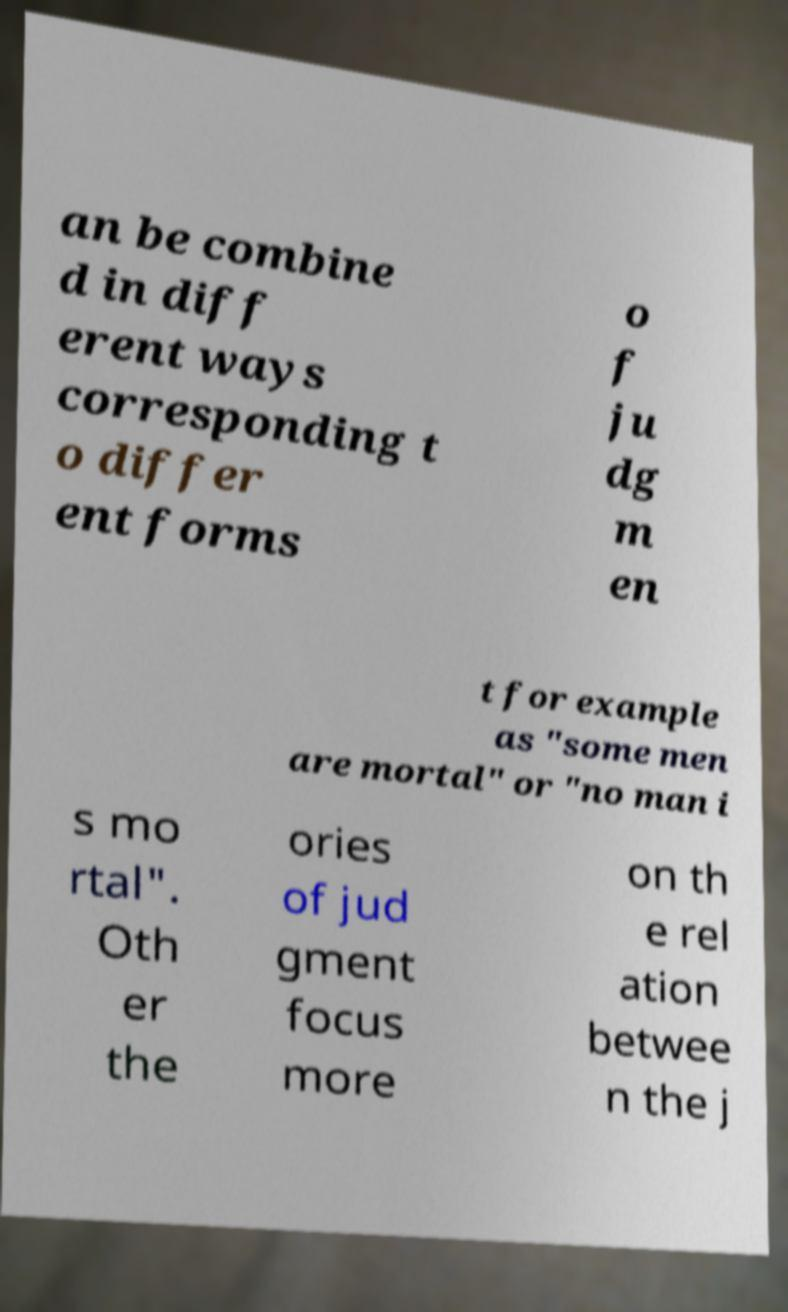Please read and relay the text visible in this image. What does it say? an be combine d in diff erent ways corresponding t o differ ent forms o f ju dg m en t for example as "some men are mortal" or "no man i s mo rtal". Oth er the ories of jud gment focus more on th e rel ation betwee n the j 